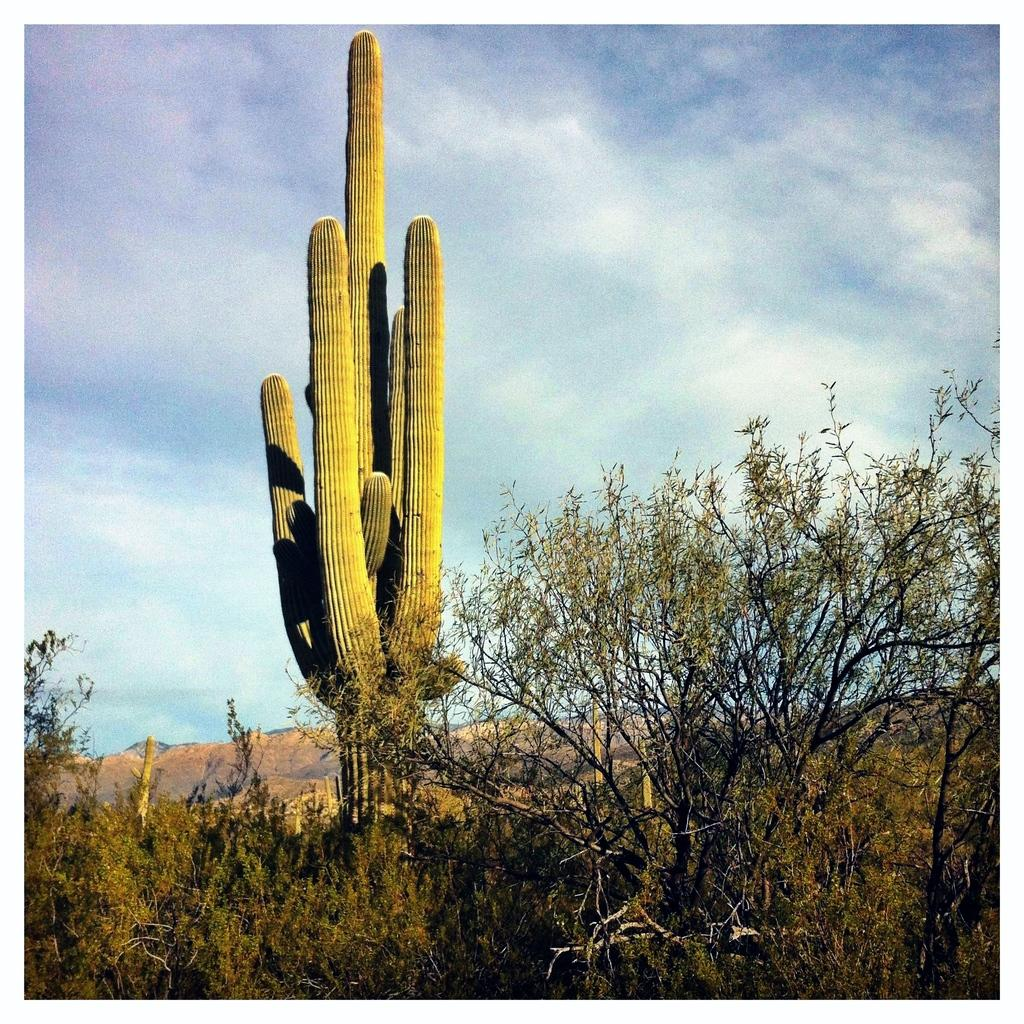What type of vegetation is in the front of the image? There are trees in the front of the image. What kind of tree can be seen in the middle of the image? There is a cactus tree in the middle of the image. What is visible in the background of the image? The sky is visible in the image. What can be observed in the sky? Clouds are present in the sky. What type of curtain can be seen hanging in the wilderness in the image? There is no curtain present in the image, and the image does not depict a wilderness setting. 